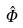<formula> <loc_0><loc_0><loc_500><loc_500>\hat { \Phi }</formula> 